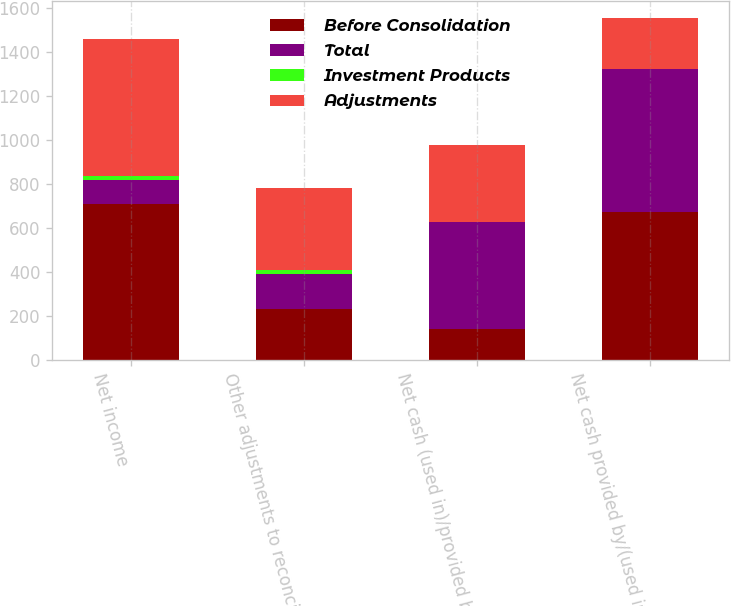Convert chart to OTSL. <chart><loc_0><loc_0><loc_500><loc_500><stacked_bar_chart><ecel><fcel>Net income<fcel>Other adjustments to reconcile<fcel>Net cash (used in)/provided by<fcel>Net cash provided by/(used in)<nl><fcel>Before Consolidation<fcel>709.4<fcel>231.4<fcel>138.4<fcel>673.6<nl><fcel>Total<fcel>107.5<fcel>159.2<fcel>487.6<fcel>649.6<nl><fcel>Investment Products<fcel>20.1<fcel>20.1<fcel>1.1<fcel>1.1<nl><fcel>Adjustments<fcel>622<fcel>370.5<fcel>348.1<fcel>231.4<nl></chart> 